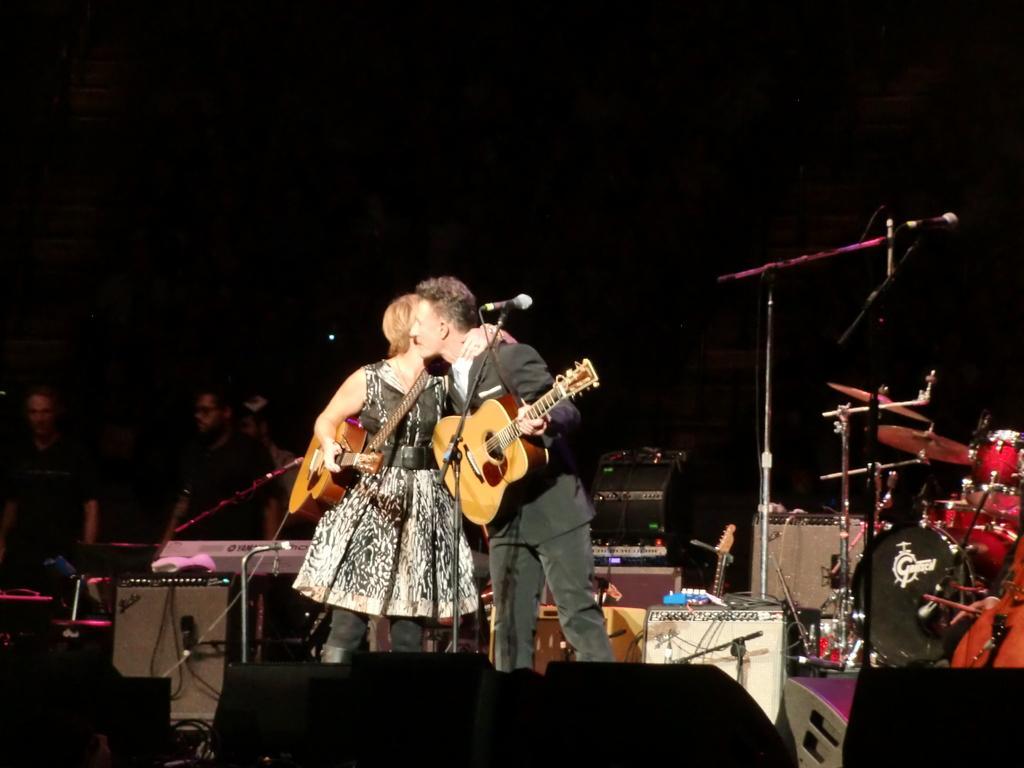Can you describe this image briefly? in this image i can see a there are two persons standing middle of the image. on the right there is a person wearing a black color jacket holding a guitar they both are hugging to each other. And a woman stand beside him wearing a black color gown she holding a guitar. back side of her there are the persons standing. and there are some musical instruments kept right side of the image. 